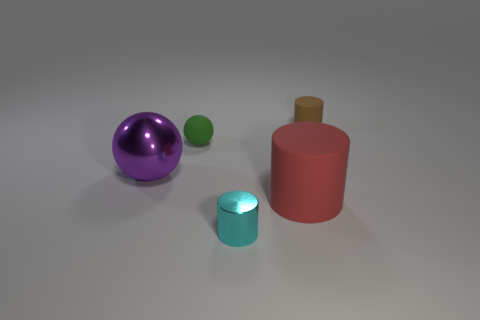Add 4 green balls. How many objects exist? 9 Subtract all cylinders. How many objects are left? 2 Add 3 small metallic objects. How many small metallic objects exist? 4 Subtract 0 green cubes. How many objects are left? 5 Subtract all small cyan shiny objects. Subtract all big matte things. How many objects are left? 3 Add 3 brown cylinders. How many brown cylinders are left? 4 